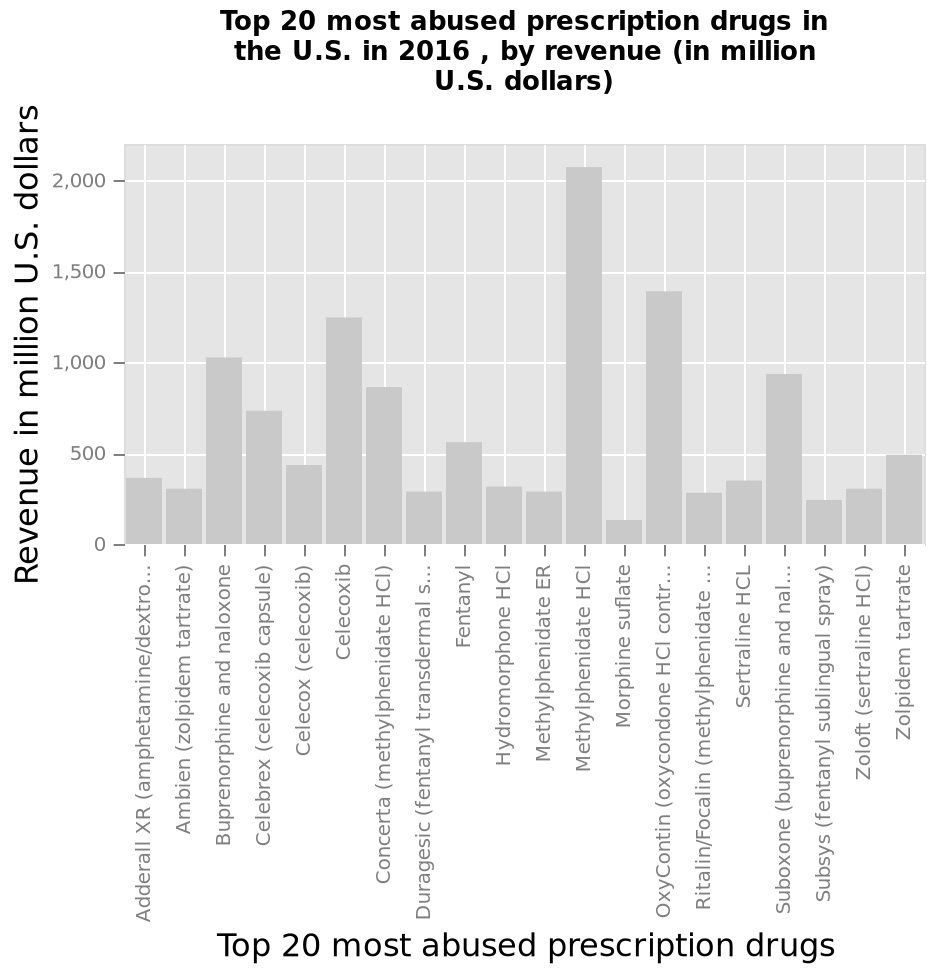<image>
Which drug generates the highest revenue? Methylphenidate hci generates the highest revenue. What does the bar graph display?  The bar graph displays the revenue (in million U.S. dollars) of the top 20 most abused prescription drugs in the U.S. in 2016. Offer a thorough analysis of the image. The most abused prescription drug in the Us in 2016 has been methylphenidate HCI with morphine sulphate being used the least. 